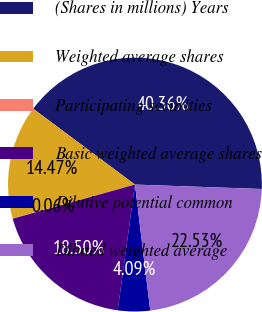Convert chart. <chart><loc_0><loc_0><loc_500><loc_500><pie_chart><fcel>(Shares in millions) Years<fcel>Weighted average shares<fcel>Participating securities<fcel>Basic weighted average shares<fcel>Dilutive potential common<fcel>Diluted weighted average<nl><fcel>40.36%<fcel>14.47%<fcel>0.06%<fcel>18.5%<fcel>4.09%<fcel>22.53%<nl></chart> 